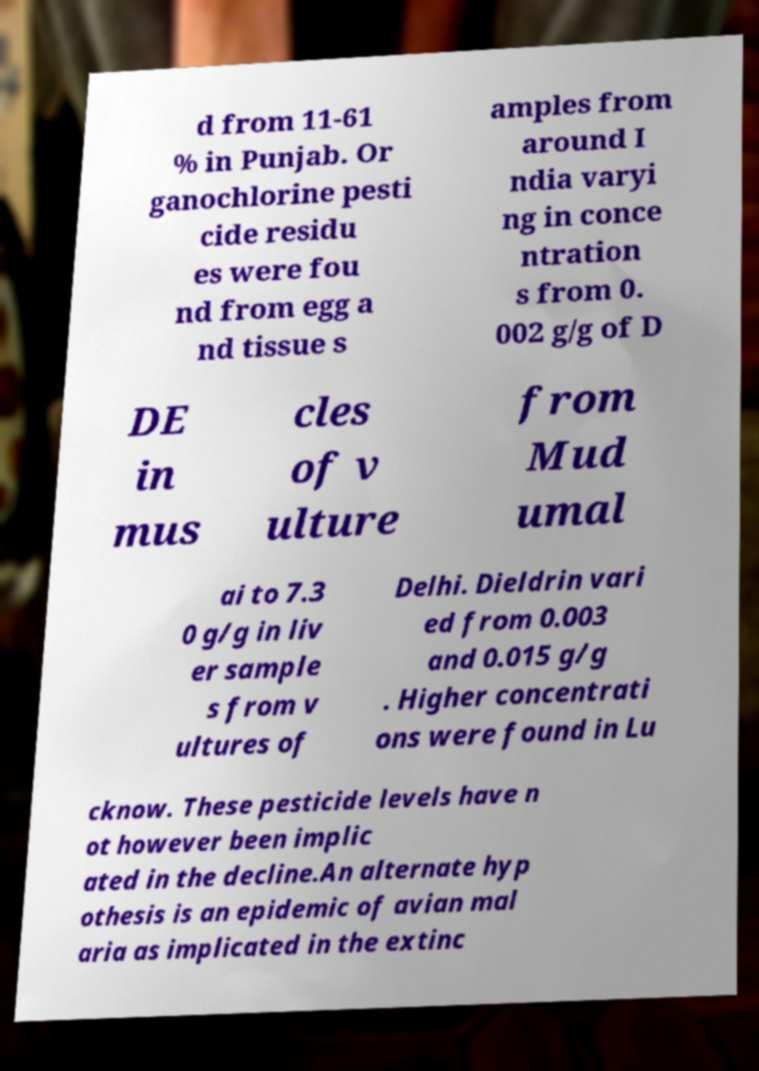Can you accurately transcribe the text from the provided image for me? d from 11-61 % in Punjab. Or ganochlorine pesti cide residu es were fou nd from egg a nd tissue s amples from around I ndia varyi ng in conce ntration s from 0. 002 g/g of D DE in mus cles of v ulture from Mud umal ai to 7.3 0 g/g in liv er sample s from v ultures of Delhi. Dieldrin vari ed from 0.003 and 0.015 g/g . Higher concentrati ons were found in Lu cknow. These pesticide levels have n ot however been implic ated in the decline.An alternate hyp othesis is an epidemic of avian mal aria as implicated in the extinc 